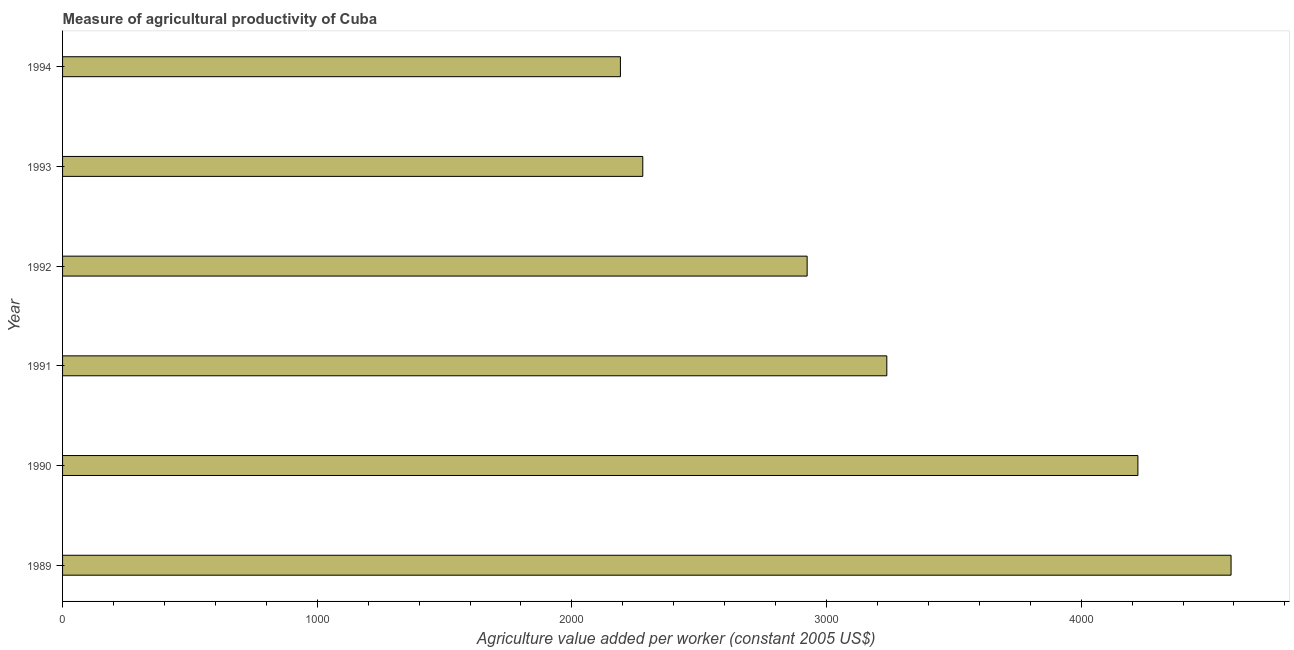Does the graph contain any zero values?
Offer a terse response. No. What is the title of the graph?
Provide a succinct answer. Measure of agricultural productivity of Cuba. What is the label or title of the X-axis?
Keep it short and to the point. Agriculture value added per worker (constant 2005 US$). What is the agriculture value added per worker in 1994?
Provide a short and direct response. 2190.66. Across all years, what is the maximum agriculture value added per worker?
Keep it short and to the point. 4588.64. Across all years, what is the minimum agriculture value added per worker?
Your response must be concise. 2190.66. In which year was the agriculture value added per worker maximum?
Your answer should be very brief. 1989. In which year was the agriculture value added per worker minimum?
Your answer should be very brief. 1994. What is the sum of the agriculture value added per worker?
Ensure brevity in your answer.  1.94e+04. What is the difference between the agriculture value added per worker in 1989 and 1994?
Provide a short and direct response. 2397.98. What is the average agriculture value added per worker per year?
Your answer should be very brief. 3240.21. What is the median agriculture value added per worker?
Give a very brief answer. 3080.34. Do a majority of the years between 1991 and 1990 (inclusive) have agriculture value added per worker greater than 3200 US$?
Keep it short and to the point. No. What is the ratio of the agriculture value added per worker in 1989 to that in 1994?
Give a very brief answer. 2.1. Is the agriculture value added per worker in 1991 less than that in 1993?
Make the answer very short. No. Is the difference between the agriculture value added per worker in 1989 and 1994 greater than the difference between any two years?
Give a very brief answer. Yes. What is the difference between the highest and the second highest agriculture value added per worker?
Your answer should be compact. 365.85. Is the sum of the agriculture value added per worker in 1989 and 1992 greater than the maximum agriculture value added per worker across all years?
Provide a succinct answer. Yes. What is the difference between the highest and the lowest agriculture value added per worker?
Provide a succinct answer. 2397.98. In how many years, is the agriculture value added per worker greater than the average agriculture value added per worker taken over all years?
Your answer should be very brief. 2. How many bars are there?
Make the answer very short. 6. Are all the bars in the graph horizontal?
Your answer should be compact. Yes. How many years are there in the graph?
Your response must be concise. 6. What is the Agriculture value added per worker (constant 2005 US$) in 1989?
Give a very brief answer. 4588.64. What is the Agriculture value added per worker (constant 2005 US$) of 1990?
Provide a short and direct response. 4222.79. What is the Agriculture value added per worker (constant 2005 US$) of 1991?
Provide a short and direct response. 3236.79. What is the Agriculture value added per worker (constant 2005 US$) in 1992?
Give a very brief answer. 2923.9. What is the Agriculture value added per worker (constant 2005 US$) in 1993?
Offer a terse response. 2278.5. What is the Agriculture value added per worker (constant 2005 US$) in 1994?
Ensure brevity in your answer.  2190.66. What is the difference between the Agriculture value added per worker (constant 2005 US$) in 1989 and 1990?
Your response must be concise. 365.85. What is the difference between the Agriculture value added per worker (constant 2005 US$) in 1989 and 1991?
Your answer should be very brief. 1351.85. What is the difference between the Agriculture value added per worker (constant 2005 US$) in 1989 and 1992?
Keep it short and to the point. 1664.74. What is the difference between the Agriculture value added per worker (constant 2005 US$) in 1989 and 1993?
Ensure brevity in your answer.  2310.14. What is the difference between the Agriculture value added per worker (constant 2005 US$) in 1989 and 1994?
Keep it short and to the point. 2397.98. What is the difference between the Agriculture value added per worker (constant 2005 US$) in 1990 and 1991?
Provide a short and direct response. 986. What is the difference between the Agriculture value added per worker (constant 2005 US$) in 1990 and 1992?
Your answer should be very brief. 1298.89. What is the difference between the Agriculture value added per worker (constant 2005 US$) in 1990 and 1993?
Ensure brevity in your answer.  1944.28. What is the difference between the Agriculture value added per worker (constant 2005 US$) in 1990 and 1994?
Provide a short and direct response. 2032.12. What is the difference between the Agriculture value added per worker (constant 2005 US$) in 1991 and 1992?
Ensure brevity in your answer.  312.89. What is the difference between the Agriculture value added per worker (constant 2005 US$) in 1991 and 1993?
Offer a very short reply. 958.28. What is the difference between the Agriculture value added per worker (constant 2005 US$) in 1991 and 1994?
Offer a very short reply. 1046.12. What is the difference between the Agriculture value added per worker (constant 2005 US$) in 1992 and 1993?
Offer a terse response. 645.39. What is the difference between the Agriculture value added per worker (constant 2005 US$) in 1992 and 1994?
Keep it short and to the point. 733.23. What is the difference between the Agriculture value added per worker (constant 2005 US$) in 1993 and 1994?
Make the answer very short. 87.84. What is the ratio of the Agriculture value added per worker (constant 2005 US$) in 1989 to that in 1990?
Make the answer very short. 1.09. What is the ratio of the Agriculture value added per worker (constant 2005 US$) in 1989 to that in 1991?
Provide a short and direct response. 1.42. What is the ratio of the Agriculture value added per worker (constant 2005 US$) in 1989 to that in 1992?
Provide a short and direct response. 1.57. What is the ratio of the Agriculture value added per worker (constant 2005 US$) in 1989 to that in 1993?
Offer a very short reply. 2.01. What is the ratio of the Agriculture value added per worker (constant 2005 US$) in 1989 to that in 1994?
Your answer should be very brief. 2.1. What is the ratio of the Agriculture value added per worker (constant 2005 US$) in 1990 to that in 1991?
Make the answer very short. 1.3. What is the ratio of the Agriculture value added per worker (constant 2005 US$) in 1990 to that in 1992?
Offer a terse response. 1.44. What is the ratio of the Agriculture value added per worker (constant 2005 US$) in 1990 to that in 1993?
Give a very brief answer. 1.85. What is the ratio of the Agriculture value added per worker (constant 2005 US$) in 1990 to that in 1994?
Offer a very short reply. 1.93. What is the ratio of the Agriculture value added per worker (constant 2005 US$) in 1991 to that in 1992?
Make the answer very short. 1.11. What is the ratio of the Agriculture value added per worker (constant 2005 US$) in 1991 to that in 1993?
Make the answer very short. 1.42. What is the ratio of the Agriculture value added per worker (constant 2005 US$) in 1991 to that in 1994?
Your answer should be compact. 1.48. What is the ratio of the Agriculture value added per worker (constant 2005 US$) in 1992 to that in 1993?
Your answer should be very brief. 1.28. What is the ratio of the Agriculture value added per worker (constant 2005 US$) in 1992 to that in 1994?
Offer a terse response. 1.33. 